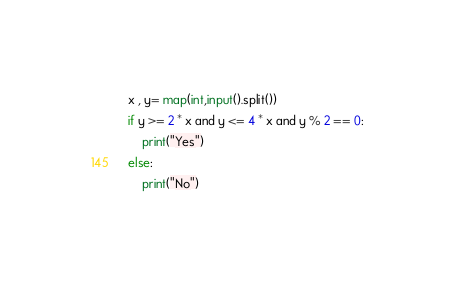<code> <loc_0><loc_0><loc_500><loc_500><_Python_>x , y= map(int,input().split())
if y >= 2 * x and y <= 4 * x and y % 2 == 0:
    print("Yes")
else:
    print("No")</code> 